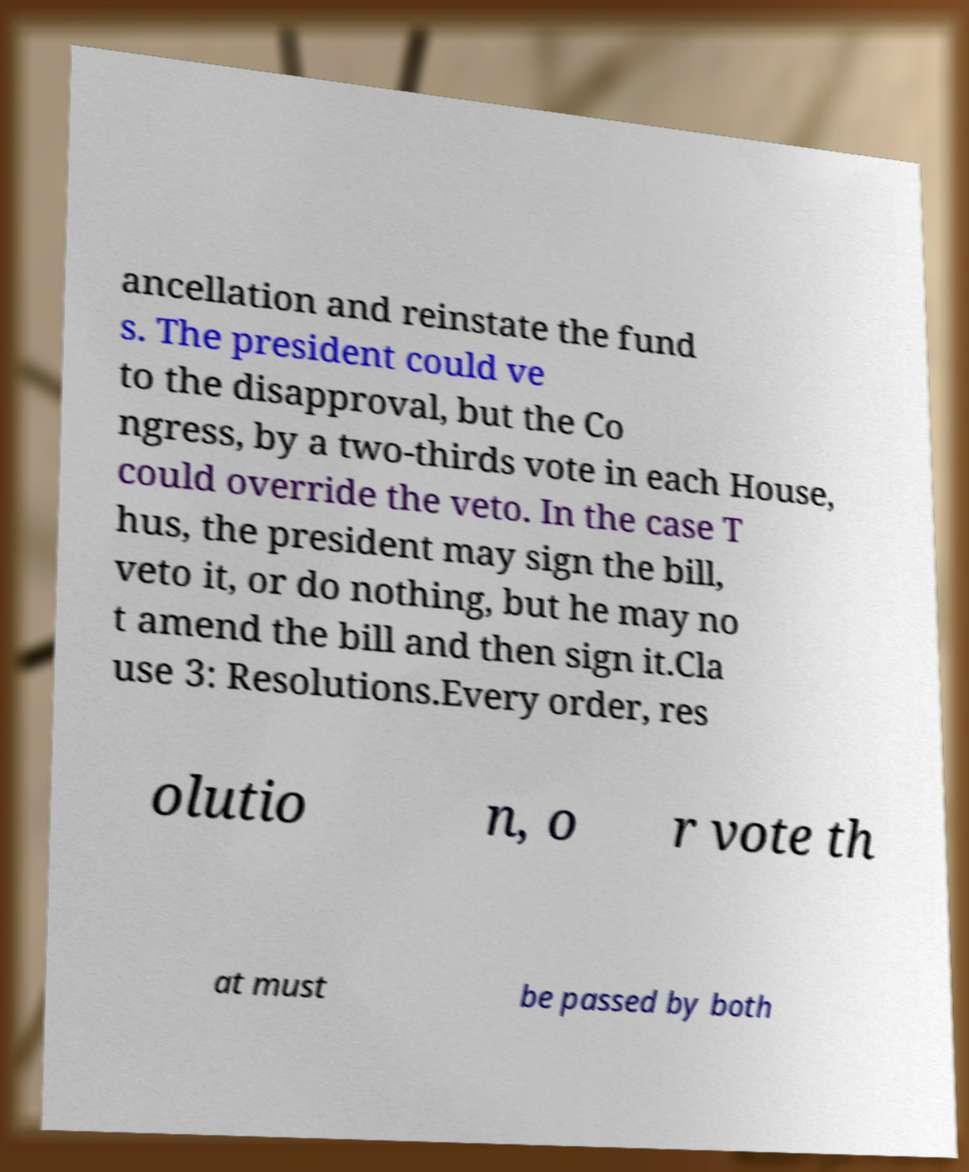Please read and relay the text visible in this image. What does it say? ancellation and reinstate the fund s. The president could ve to the disapproval, but the Co ngress, by a two-thirds vote in each House, could override the veto. In the case T hus, the president may sign the bill, veto it, or do nothing, but he may no t amend the bill and then sign it.Cla use 3: Resolutions.Every order, res olutio n, o r vote th at must be passed by both 